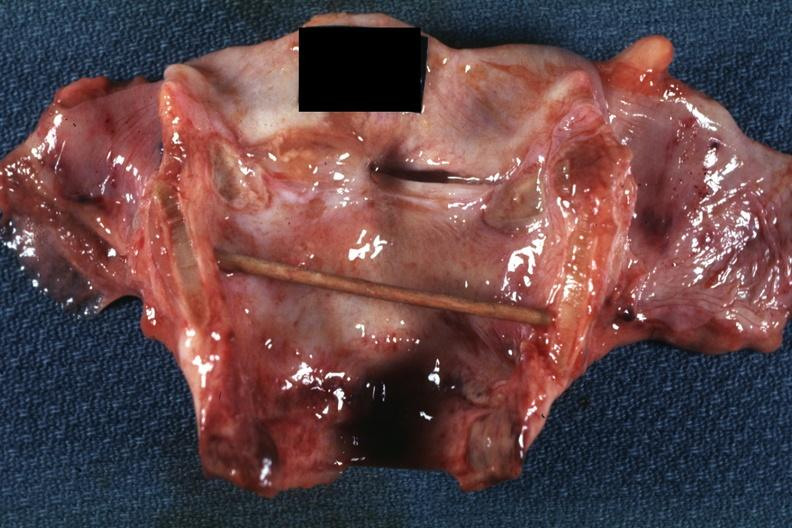does this image show excellent example intubation lesion with tracheitis?
Answer the question using a single word or phrase. Yes 